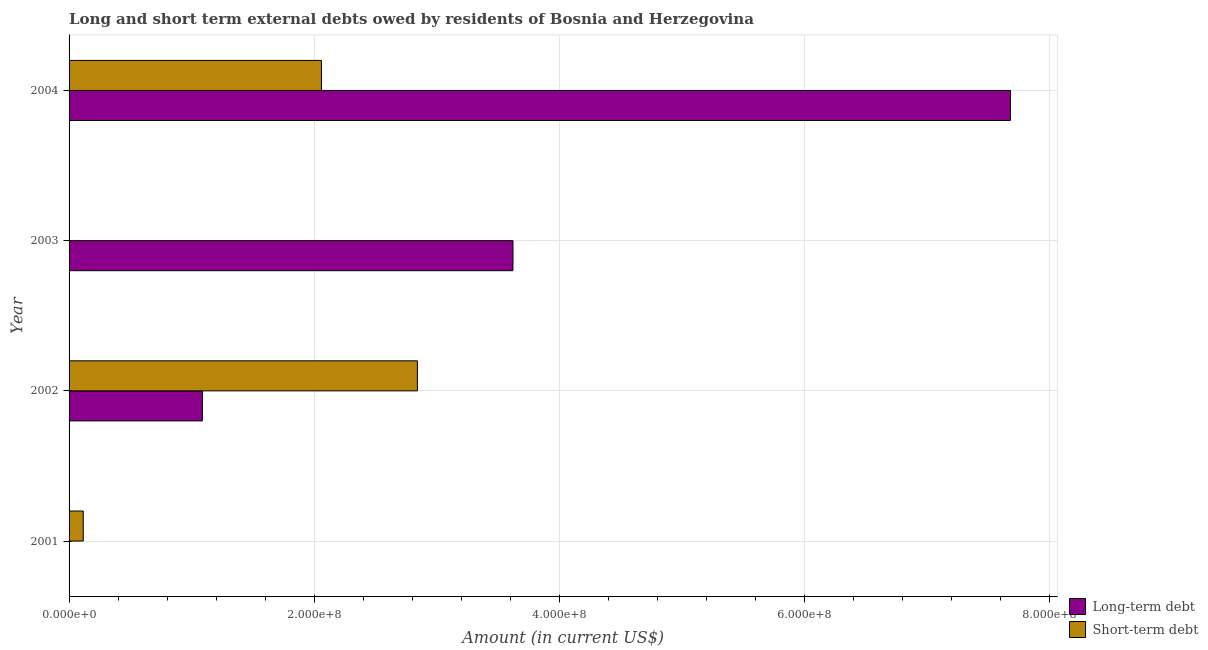How many different coloured bars are there?
Keep it short and to the point. 2. Are the number of bars on each tick of the Y-axis equal?
Ensure brevity in your answer.  No. How many bars are there on the 1st tick from the bottom?
Give a very brief answer. 1. What is the label of the 3rd group of bars from the top?
Ensure brevity in your answer.  2002. What is the long-term debts owed by residents in 2003?
Provide a short and direct response. 3.62e+08. Across all years, what is the maximum long-term debts owed by residents?
Your answer should be very brief. 7.68e+08. In which year was the short-term debts owed by residents maximum?
Provide a succinct answer. 2002. What is the total long-term debts owed by residents in the graph?
Give a very brief answer. 1.24e+09. What is the difference between the short-term debts owed by residents in 2002 and that in 2004?
Keep it short and to the point. 7.83e+07. What is the difference between the long-term debts owed by residents in 2004 and the short-term debts owed by residents in 2002?
Give a very brief answer. 4.84e+08. What is the average long-term debts owed by residents per year?
Your answer should be very brief. 3.10e+08. In the year 2002, what is the difference between the short-term debts owed by residents and long-term debts owed by residents?
Give a very brief answer. 1.75e+08. In how many years, is the short-term debts owed by residents greater than 520000000 US$?
Offer a terse response. 0. What is the ratio of the short-term debts owed by residents in 2001 to that in 2002?
Provide a short and direct response. 0.04. What is the difference between the highest and the second highest long-term debts owed by residents?
Give a very brief answer. 4.06e+08. What is the difference between the highest and the lowest long-term debts owed by residents?
Provide a short and direct response. 7.68e+08. Does the graph contain grids?
Your response must be concise. Yes. How are the legend labels stacked?
Provide a succinct answer. Vertical. What is the title of the graph?
Offer a terse response. Long and short term external debts owed by residents of Bosnia and Herzegovina. Does "Old" appear as one of the legend labels in the graph?
Offer a very short reply. No. What is the label or title of the Y-axis?
Ensure brevity in your answer.  Year. What is the Amount (in current US$) in Long-term debt in 2001?
Provide a succinct answer. 0. What is the Amount (in current US$) in Short-term debt in 2001?
Your answer should be compact. 1.16e+07. What is the Amount (in current US$) of Long-term debt in 2002?
Your answer should be very brief. 1.09e+08. What is the Amount (in current US$) of Short-term debt in 2002?
Give a very brief answer. 2.84e+08. What is the Amount (in current US$) in Long-term debt in 2003?
Give a very brief answer. 3.62e+08. What is the Amount (in current US$) of Long-term debt in 2004?
Give a very brief answer. 7.68e+08. What is the Amount (in current US$) of Short-term debt in 2004?
Give a very brief answer. 2.06e+08. Across all years, what is the maximum Amount (in current US$) of Long-term debt?
Ensure brevity in your answer.  7.68e+08. Across all years, what is the maximum Amount (in current US$) in Short-term debt?
Your answer should be very brief. 2.84e+08. Across all years, what is the minimum Amount (in current US$) in Long-term debt?
Give a very brief answer. 0. Across all years, what is the minimum Amount (in current US$) of Short-term debt?
Ensure brevity in your answer.  0. What is the total Amount (in current US$) in Long-term debt in the graph?
Provide a succinct answer. 1.24e+09. What is the total Amount (in current US$) of Short-term debt in the graph?
Keep it short and to the point. 5.02e+08. What is the difference between the Amount (in current US$) in Short-term debt in 2001 and that in 2002?
Give a very brief answer. -2.73e+08. What is the difference between the Amount (in current US$) of Short-term debt in 2001 and that in 2004?
Your answer should be compact. -1.94e+08. What is the difference between the Amount (in current US$) of Long-term debt in 2002 and that in 2003?
Offer a terse response. -2.53e+08. What is the difference between the Amount (in current US$) of Long-term debt in 2002 and that in 2004?
Keep it short and to the point. -6.59e+08. What is the difference between the Amount (in current US$) in Short-term debt in 2002 and that in 2004?
Your response must be concise. 7.83e+07. What is the difference between the Amount (in current US$) of Long-term debt in 2003 and that in 2004?
Provide a short and direct response. -4.06e+08. What is the difference between the Amount (in current US$) in Long-term debt in 2002 and the Amount (in current US$) in Short-term debt in 2004?
Ensure brevity in your answer.  -9.72e+07. What is the difference between the Amount (in current US$) in Long-term debt in 2003 and the Amount (in current US$) in Short-term debt in 2004?
Your answer should be very brief. 1.56e+08. What is the average Amount (in current US$) of Long-term debt per year?
Give a very brief answer. 3.10e+08. What is the average Amount (in current US$) in Short-term debt per year?
Offer a terse response. 1.25e+08. In the year 2002, what is the difference between the Amount (in current US$) in Long-term debt and Amount (in current US$) in Short-term debt?
Offer a terse response. -1.75e+08. In the year 2004, what is the difference between the Amount (in current US$) of Long-term debt and Amount (in current US$) of Short-term debt?
Keep it short and to the point. 5.62e+08. What is the ratio of the Amount (in current US$) of Short-term debt in 2001 to that in 2002?
Provide a short and direct response. 0.04. What is the ratio of the Amount (in current US$) in Short-term debt in 2001 to that in 2004?
Your answer should be very brief. 0.06. What is the ratio of the Amount (in current US$) in Long-term debt in 2002 to that in 2003?
Offer a very short reply. 0.3. What is the ratio of the Amount (in current US$) in Long-term debt in 2002 to that in 2004?
Offer a terse response. 0.14. What is the ratio of the Amount (in current US$) in Short-term debt in 2002 to that in 2004?
Provide a succinct answer. 1.38. What is the ratio of the Amount (in current US$) in Long-term debt in 2003 to that in 2004?
Give a very brief answer. 0.47. What is the difference between the highest and the second highest Amount (in current US$) in Long-term debt?
Ensure brevity in your answer.  4.06e+08. What is the difference between the highest and the second highest Amount (in current US$) of Short-term debt?
Make the answer very short. 7.83e+07. What is the difference between the highest and the lowest Amount (in current US$) of Long-term debt?
Make the answer very short. 7.68e+08. What is the difference between the highest and the lowest Amount (in current US$) of Short-term debt?
Provide a succinct answer. 2.84e+08. 